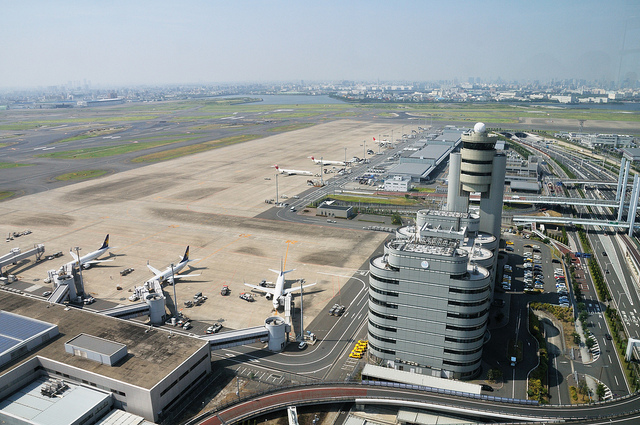<image>Are these planes commuter planes or private jets? It is unknown whether these are commuter planes or private jets. But most people think they are commuter planes. Are these planes commuter planes or private jets? I don't know if these planes are commuter planes or private jets. It can be both. 